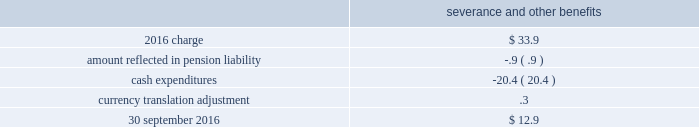As of 30 september 2016 and 2015 , there were no assets or liabilities classified as discontinued operations relating to the homecare business .
Business restructuring and cost reduction actions the charges we record for business restructuring and cost reduction actions have been excluded from segment operating income .
Cost reduction actions in fiscal year 2016 , we recognized an expense of $ 33.9 ( $ 24.0 after-tax , or $ .11 per share ) for severance and other benefits related to cost reduction actions which resulted in the elimination of approximately 700 positions .
The expenses related primarily to the industrial gases 2013 americas and the industrial gases 2013 emea segments .
The table summarizes the carrying amount of the accrual for cost reduction actions at 30 september severance and other benefits .
Business realignment and reorganization on 18 september 2014 , we announced plans to reorganize the company , including realignment of our businesses in new reporting segments and other organizational changes , effective as of 1 october 2014 .
As a result of this reorganization , we incurred severance and other charges .
In fiscal year 2015 , we recognized an expense of $ 207.7 ( $ 153.2 after-tax , or $ .71 per share ) .
Severance and other benefits totaled $ 151.9 and related to the elimination of approximately 2000 positions .
Asset and associated contract actions totaled $ 55.8 and related primarily to a plant shutdown in the corporate and other segment and the exit of product lines within the industrial gases 2013 global and materials technologies segments .
The 2015 charges related to the segments as follows : $ 31.7 in industrial gases 2013 americas , $ 52.2 in industrial gases 2013 emea , $ 10.3 in industrial gases 2013 asia , $ 37.0 in industrial gases 2013 global , $ 27.6 in materials technologies , and $ 48.9 in corporate and other .
During the fourth quarter of 2014 , an expense of $ 12.7 ( $ 8.2 after-tax , or $ .04 per share ) was incurred relating to the elimination of approximately 50 positions .
The 2014 charge related to the segments as follows : $ 2.9 in industrial gases 2013 americas , $ 3.1 in industrial gases 2013 emea , $ 1.5 in industrial gases 2013 asia , $ 1.5 in industrial gases 2013 global , $ 1.6 in materials technologies , and $ 2.1 in corporate and other. .
Considering the 2015's charge , what is the impact of the industrial gases 2013 americas segment concerning the total expenses? 
Rationale: it is the expense related to the industrial gases 2013 americas segment divided by the total charge , then turned into a percentage .
Computations: (31.7 / 207.7)
Answer: 0.15262. 